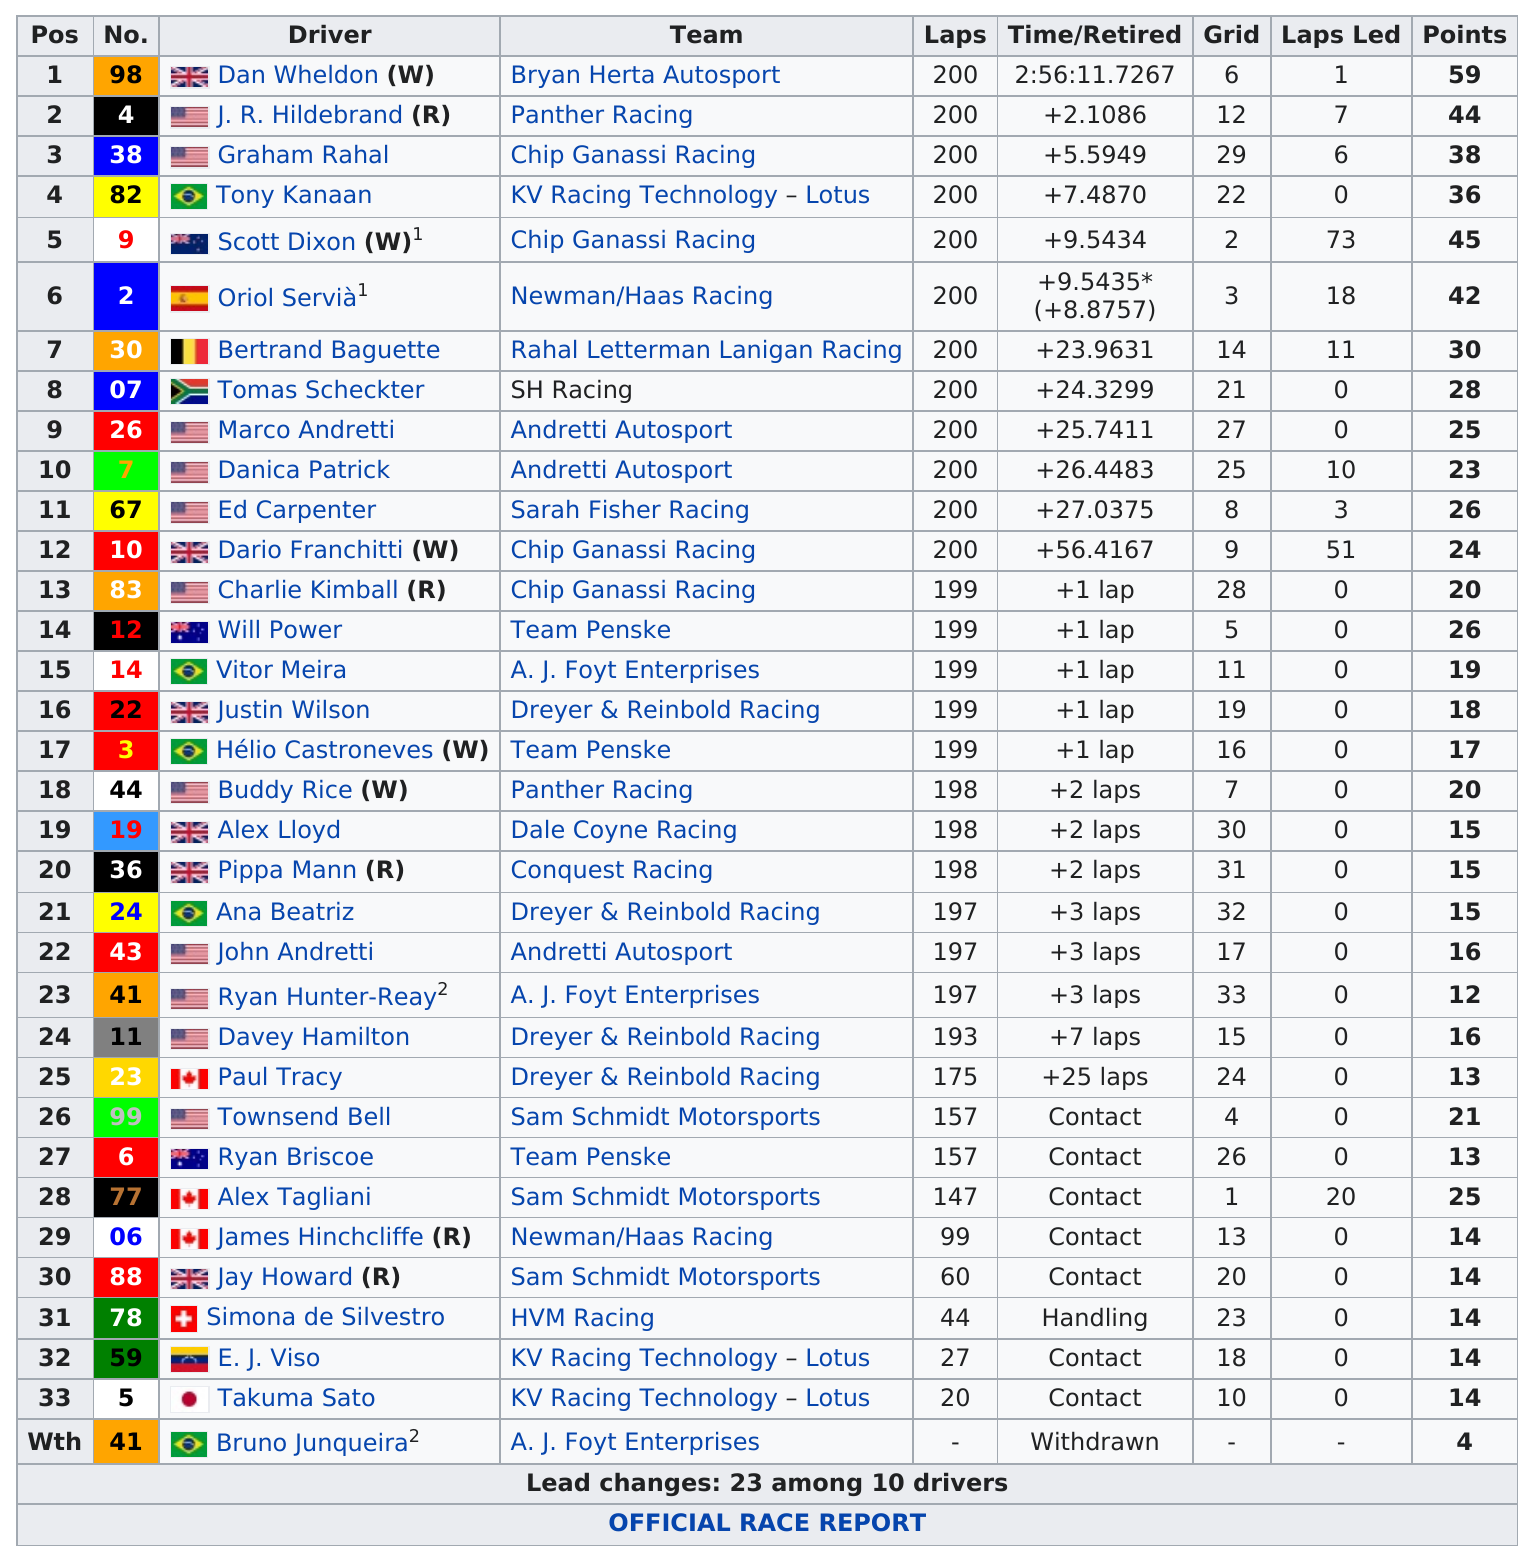List a handful of essential elements in this visual. Dan Wheldon, who raced the fastest, won the competition. It is confirmed that Danica Patrick came in after Marco Andretti. Pippa Mann completed 198 laps. Bruno Junqueira, the racer, only had 4 points. Scott Dixon led for a total of 73 laps. 